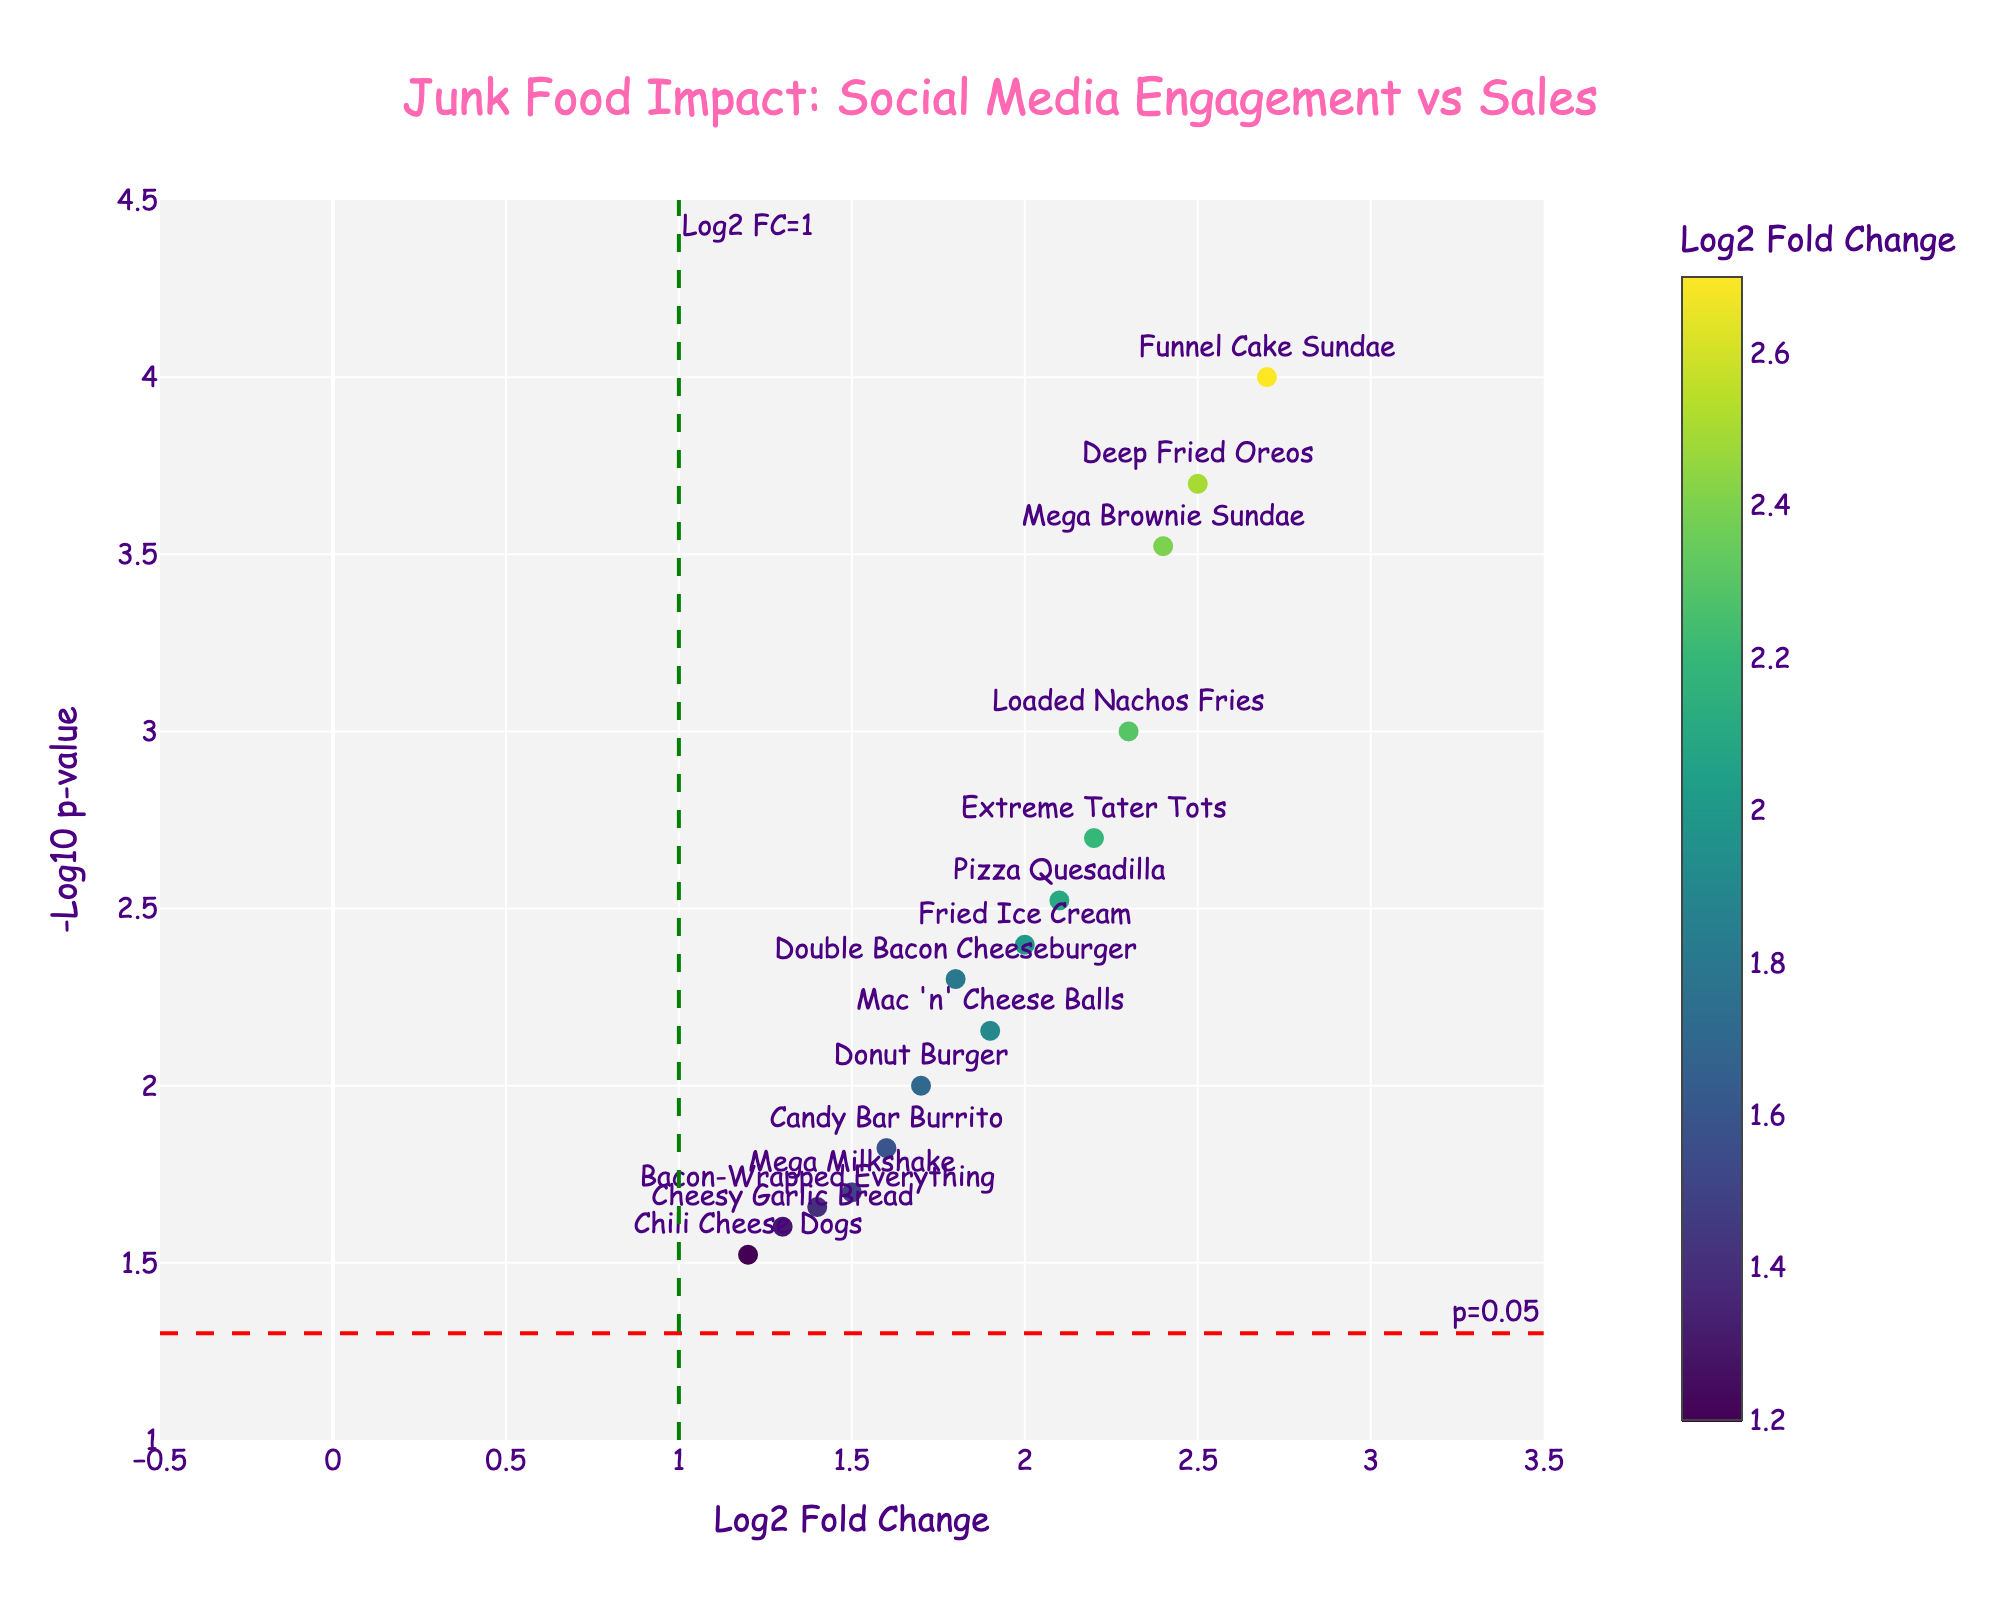what is the title of the plot? The title is displayed at the top center of the figure in large font. It reads "Junk Food Impact: Social Media Engagement vs Sales".
Answer: Junk Food Impact: Social Media Engagement vs Sales How many menu items have a p-value less than 0.05? The plot has a horizontal dashed red line at y=-log10(0.05). All points above this line have p-values less than 0.05. Count the number of points above this threshold.
Answer: 14 Which menu item has the highest Log2 Fold Change? Identify the point furthest to the right on the x-axis and check its label. The furthest right point corresponds to the highest Log2 Fold Change.
Answer: Funnel Cake Sundae What's the significance level represented by the red dashed line? The red dashed line is annotated with "p=0.05" on the figure, indicating the significance threshold.
Answer: 0.05 Which two menu items have the closest Log2 Fold Changes? Compare the horizontal positions of the points. The Double Bacon Cheeseburger (1.8) and Mac 'n' Cheese Balls (1.9) are the closest in Log2 Fold Change.
Answer: Double Bacon Cheeseburger, Mac 'n' Cheese Balls How is color used in this plot? Colors represent Log2 Fold Change values, with a color bar on the right indicating the scale from darker to brighter shades.
Answer: To represent Log2 Fold Change values What does a higher -Log10 p-value signify in terms of p-value? A higher -Log10 p-value signifies a smaller p-value, indicating higher statistical significance.
Answer: Smaller p-value Which menu item has a p-value closest to 0.01? On the y-axis, find the point nearest to the -log10(0.01), which is 2. Candy Bar Burrito is the closest to this value with 2. Candy Bar Burrito is closest to 0.01
Answer: Candy Bar Burrito Do any menu items have negative Log2 Fold Change values? Based on the plot range on the x-axis (-0.5 to 3.5), there are no points in the negative range, showing all Log2 Fold Changes are positive.
Answer: No Which menu item has the second-highest -Log10 p-value? Identify the second highest point on the y-axis and check its label. Deep Fried Oreos has the second highest -Log10 p-value.
Answer: Deep Fried Oreos 